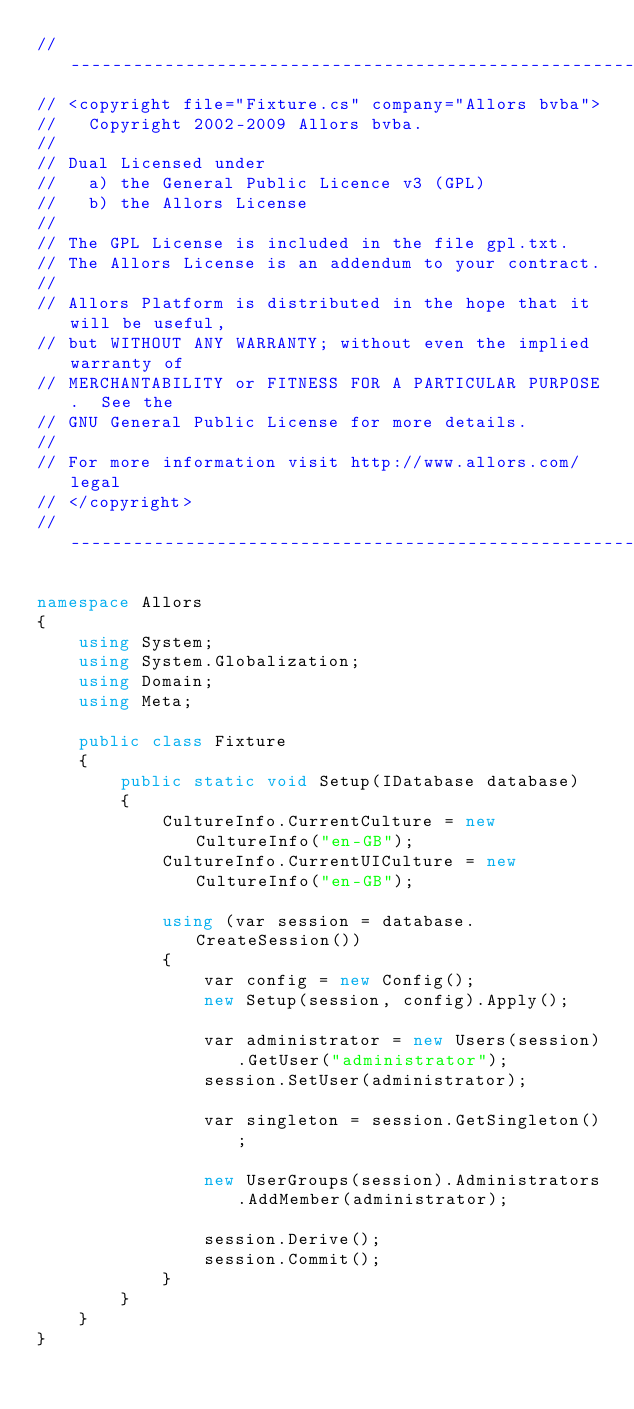<code> <loc_0><loc_0><loc_500><loc_500><_C#_>// --------------------------------------------------------------------------------------------------------------------
// <copyright file="Fixture.cs" company="Allors bvba">
//   Copyright 2002-2009 Allors bvba.
// 
// Dual Licensed under
//   a) the General Public Licence v3 (GPL)
//   b) the Allors License
// 
// The GPL License is included in the file gpl.txt.
// The Allors License is an addendum to your contract.
// 
// Allors Platform is distributed in the hope that it will be useful,
// but WITHOUT ANY WARRANTY; without even the implied warranty of
// MERCHANTABILITY or FITNESS FOR A PARTICULAR PURPOSE.  See the
// GNU General Public License for more details.
// 
// For more information visit http://www.allors.com/legal
// </copyright>
// --------------------------------------------------------------------------------------------------------------------

namespace Allors
{
    using System;
    using System.Globalization;
    using Domain;
    using Meta;

    public class Fixture
    {
        public static void Setup(IDatabase database)
        {
            CultureInfo.CurrentCulture = new CultureInfo("en-GB");
            CultureInfo.CurrentUICulture = new CultureInfo("en-GB");

            using (var session = database.CreateSession())
            {
                var config = new Config();
                new Setup(session, config).Apply();

                var administrator = new Users(session).GetUser("administrator");
                session.SetUser(administrator);

                var singleton = session.GetSingleton();

                new UserGroups(session).Administrators.AddMember(administrator);

                session.Derive();
                session.Commit();
            }
        }
    }
}</code> 